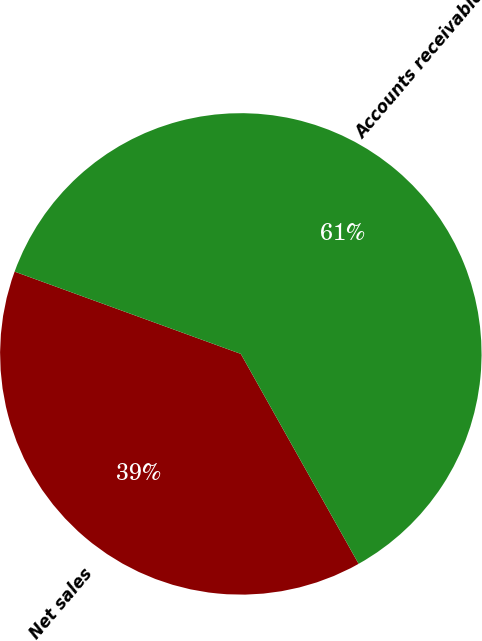<chart> <loc_0><loc_0><loc_500><loc_500><pie_chart><fcel>Net sales<fcel>Accounts receivable<nl><fcel>38.69%<fcel>61.31%<nl></chart> 